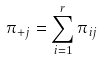Convert formula to latex. <formula><loc_0><loc_0><loc_500><loc_500>\pi _ { + j } = \sum _ { i = 1 } ^ { r } \pi _ { i j }</formula> 